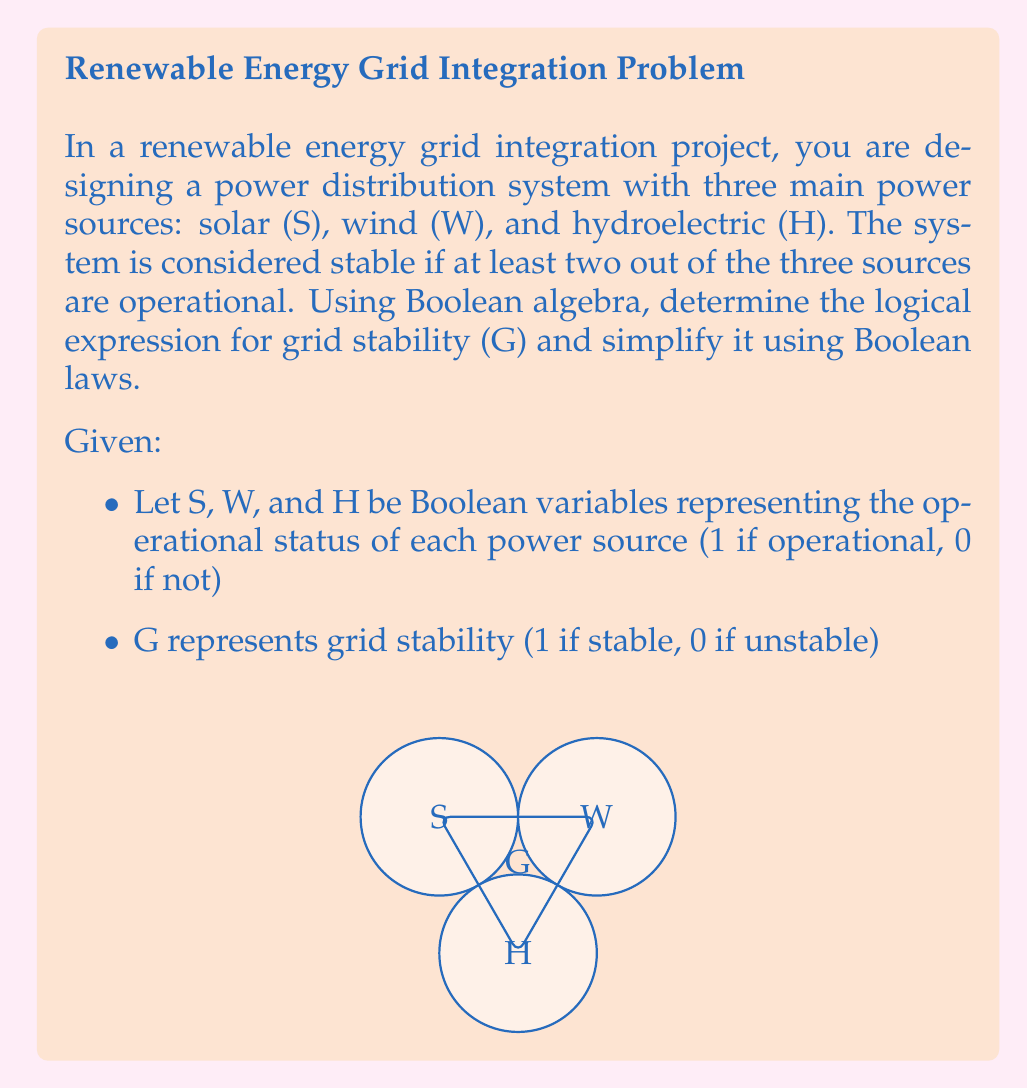Give your solution to this math problem. To solve this problem, we'll follow these steps:

1) First, let's express the grid stability condition using Boolean algebra. We need at least two sources to be operational, which can be represented as:

   $G = (S \land W) \lor (S \land H) \lor (W \land H)$

2) This expression can be expanded using the distributive law:

   $G = (S \land W) \lor (S \land H) \lor (W \land H)$

3) Now, we can apply the consensus theorem, which states that for any Boolean variables $a$, $b$, and $c$:

   $(a \land b) \lor (a \land c) \lor (b \land c) = (a \land b) \lor (a \land c) \lor (b \land c) \lor (a \land b \land c)$

4) Applying this to our expression:

   $G = (S \land W) \lor (S \land H) \lor (W \land H) \lor (S \land W \land H)$

5) This can be further simplified using the absorption law, which states that $a \lor (a \land b) = a$. Applying this three times:

   $G = (S \land W) \lor (S \land H) \lor (W \land H)$

6) This final expression is the simplest form using Boolean algebra, representing that the grid is stable if any two or all three sources are operational.
Answer: $G = (S \land W) \lor (S \land H) \lor (W \land H)$ 